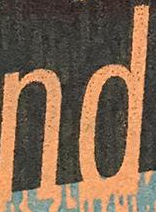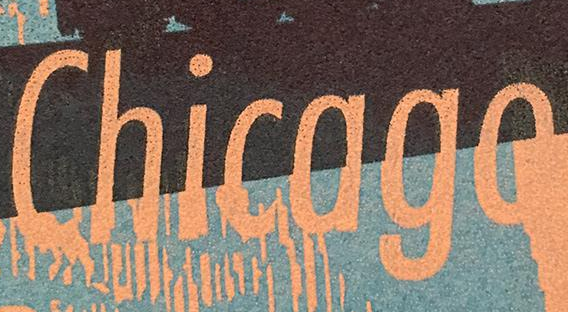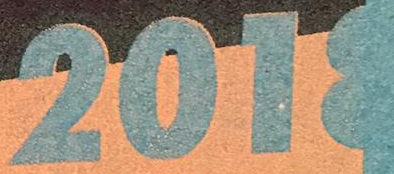What words are shown in these images in order, separated by a semicolon? nd; Chicago; 2018 